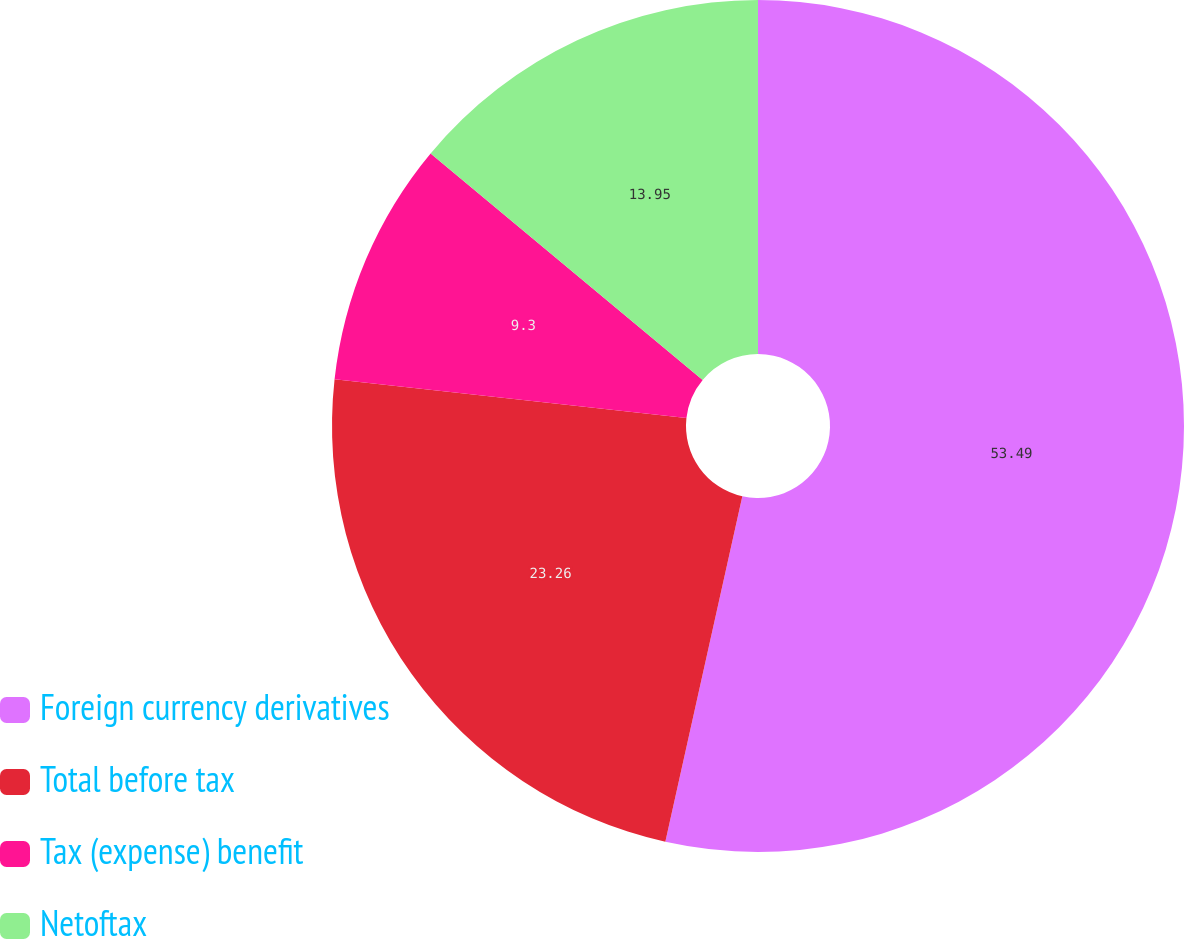<chart> <loc_0><loc_0><loc_500><loc_500><pie_chart><fcel>Foreign currency derivatives<fcel>Total before tax<fcel>Tax (expense) benefit<fcel>Netoftax<nl><fcel>53.49%<fcel>23.26%<fcel>9.3%<fcel>13.95%<nl></chart> 